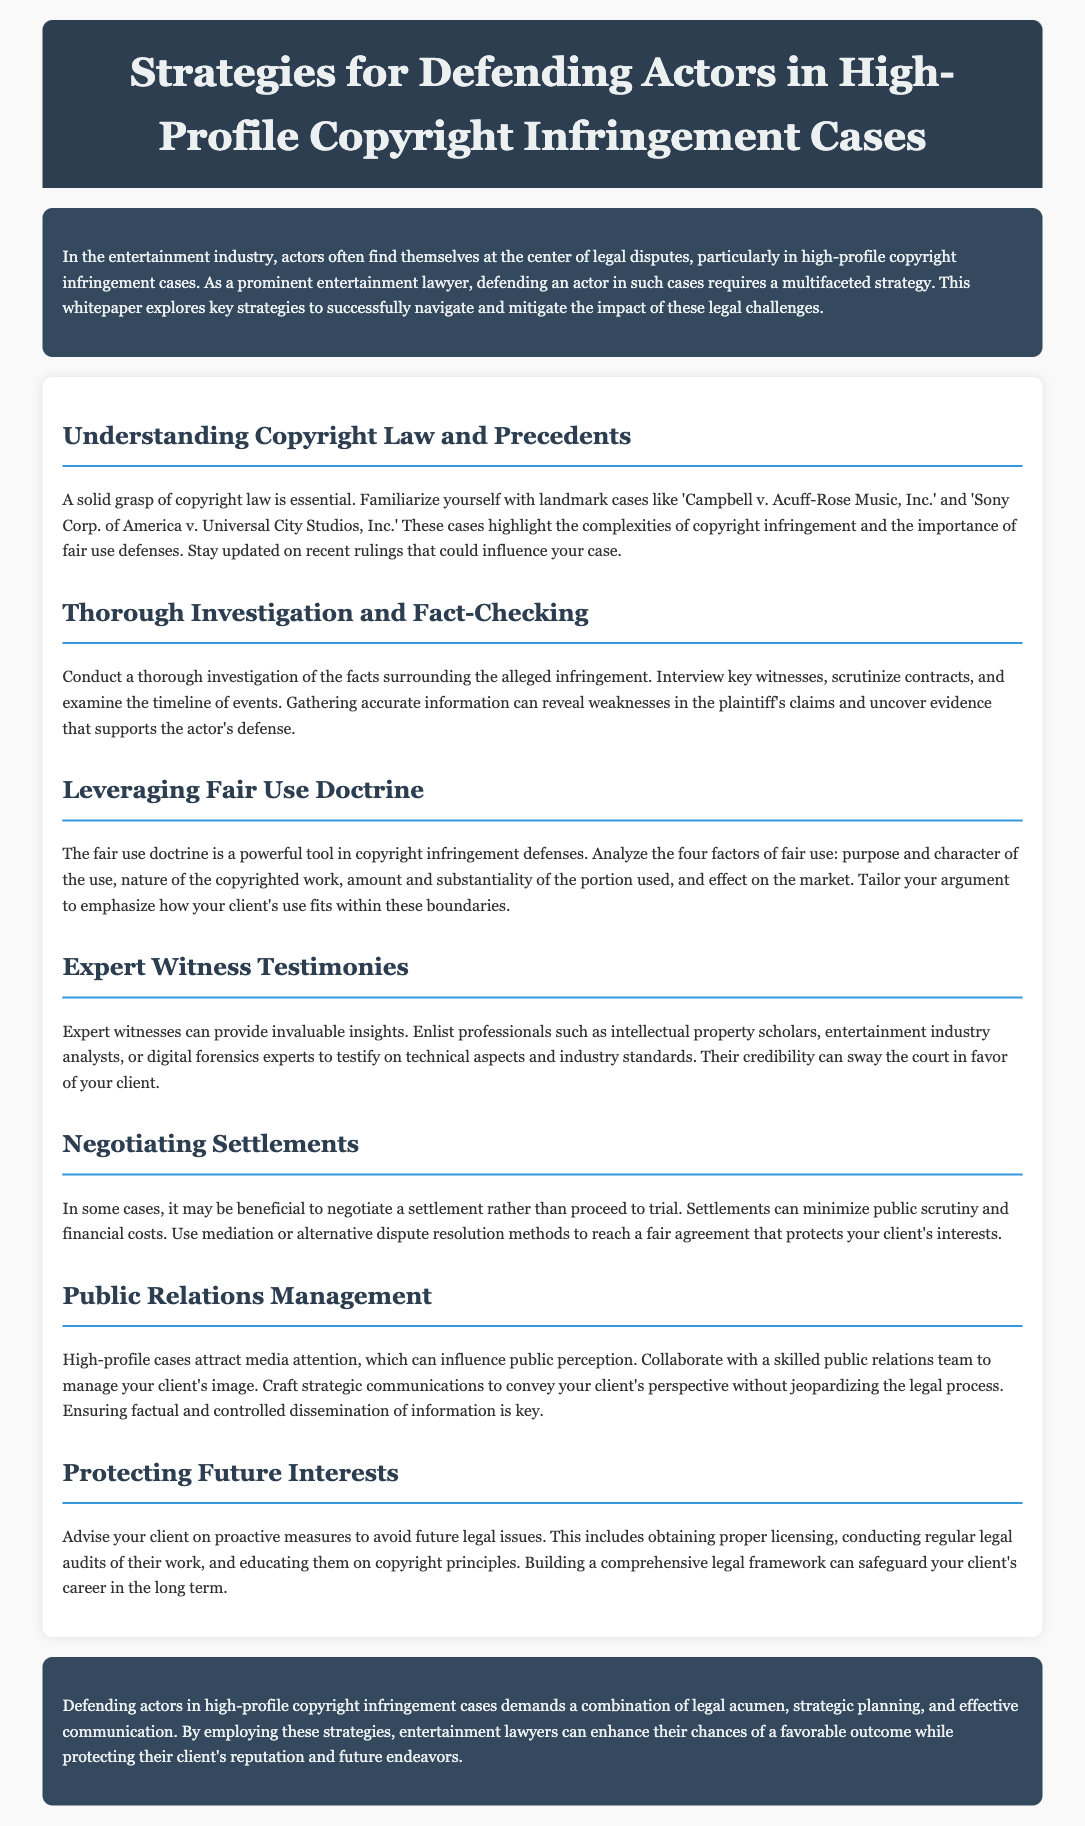What is the title of the whitepaper? The title is explicitly stated in the header of the document.
Answer: Strategies for Defending Actors in High-Profile Copyright Infringement Cases What landmark case is mentioned related to copyright law? The document lists important cases that should be familiar to lawyers defending copyright cases.
Answer: Campbell v. Acuff-Rose Music, Inc What is the first strategy outlined in the document? The sections of the document provide a structured overview of strategies.
Answer: Understanding Copyright Law and Precedents What does the fair use doctrine analyze? The document describes the four factors that are involved in fair use analysis.
Answer: Purpose and character, nature of the copyrighted work, amount used, effect on the market Why is expert witness testimony valuable? The document mentions the significance of expert witness insights during court proceedings.
Answer: Credibility What can effective public relations management influence? The whitepaper discusses the impact of media attention on high-profile cases.
Answer: Public perception What proactive measure does the document suggest for avoiding future legal issues? The document lists strategies for protecting actors from future copyright disputes.
Answer: Obtaining proper licensing In what aspect does the whitepaper emphasize strategic planning? The document details the importance of strategic communication in legal defense.
Answer: Effective communication 